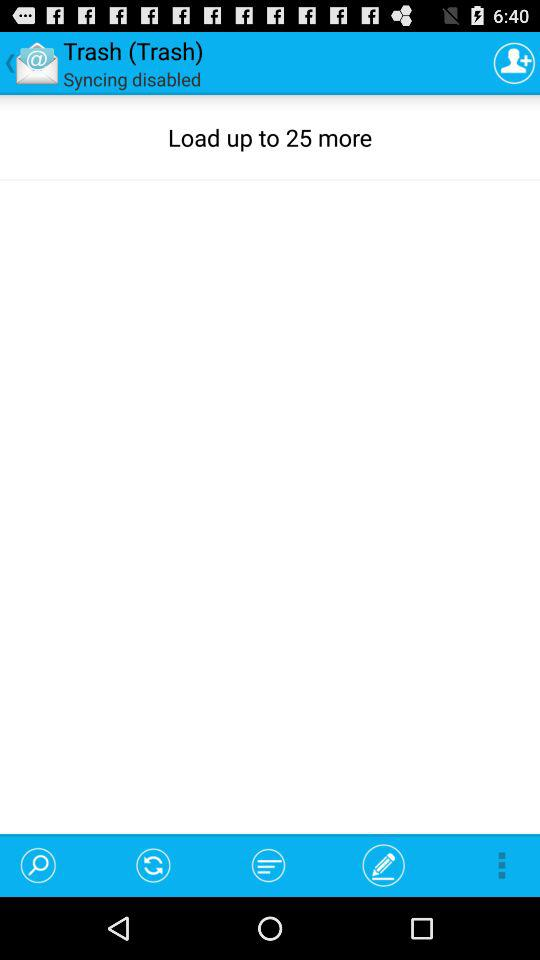How many items in "Trash" can be loaded? The number of items that can be loaded in "Trash" is up to 25. 